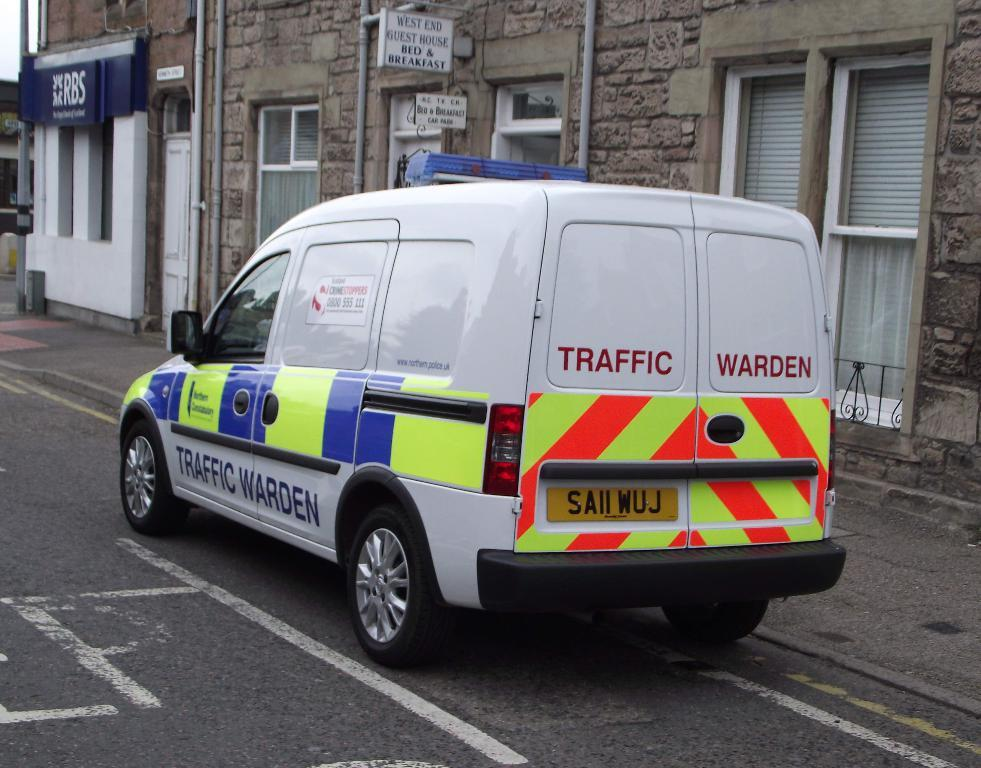<image>
Present a compact description of the photo's key features. A traffic warden van is pulled over to the right side of the street. 